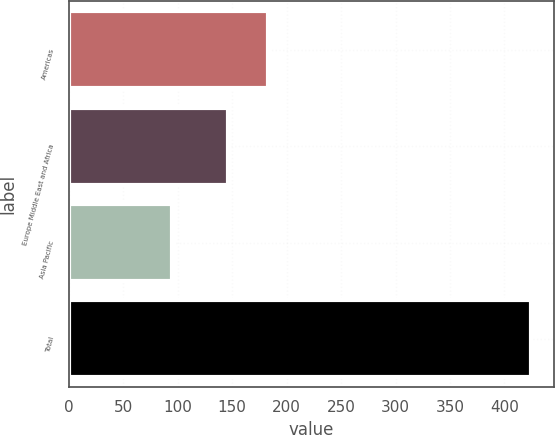<chart> <loc_0><loc_0><loc_500><loc_500><bar_chart><fcel>Americas<fcel>Europe Middle East and Africa<fcel>Asia Pacific<fcel>Total<nl><fcel>183<fcel>146<fcel>95<fcel>424<nl></chart> 